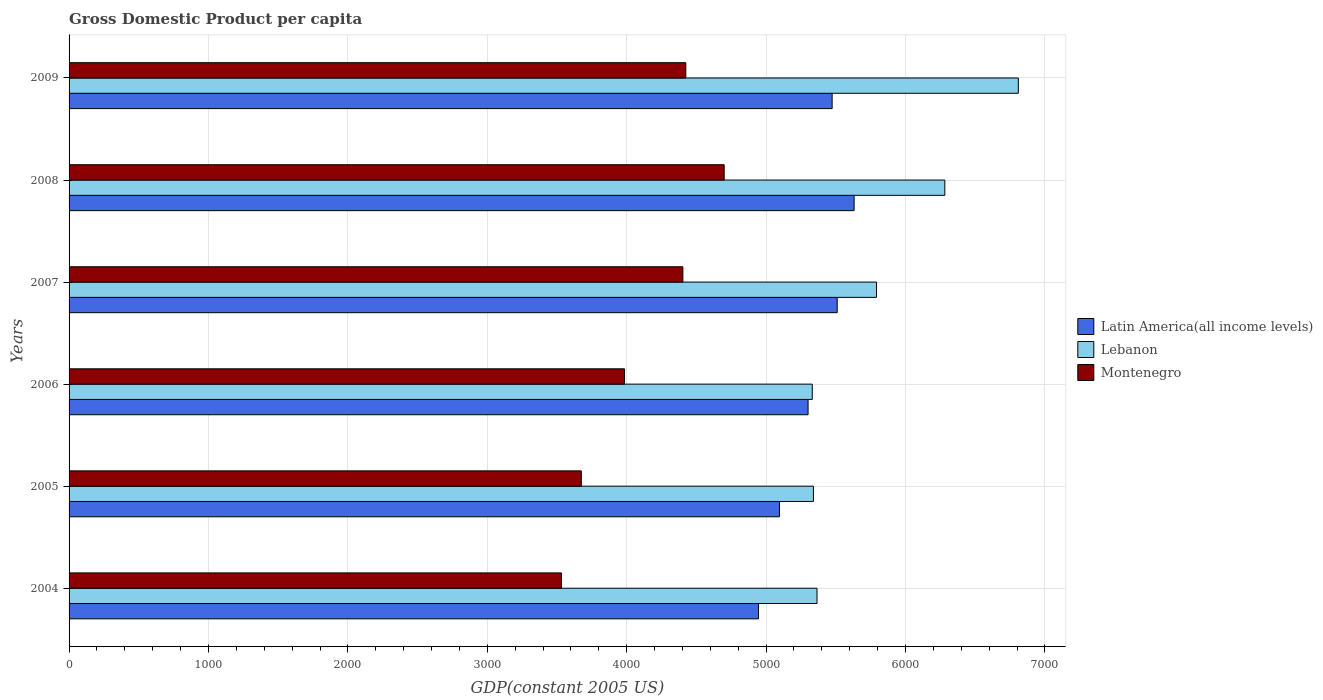How many different coloured bars are there?
Give a very brief answer. 3. Are the number of bars on each tick of the Y-axis equal?
Give a very brief answer. Yes. How many bars are there on the 5th tick from the bottom?
Make the answer very short. 3. What is the label of the 1st group of bars from the top?
Keep it short and to the point. 2009. What is the GDP per capita in Montenegro in 2009?
Provide a succinct answer. 4424.01. Across all years, what is the maximum GDP per capita in Montenegro?
Keep it short and to the point. 4699.35. Across all years, what is the minimum GDP per capita in Latin America(all income levels)?
Your answer should be very brief. 4945.3. What is the total GDP per capita in Montenegro in the graph?
Ensure brevity in your answer.  2.47e+04. What is the difference between the GDP per capita in Lebanon in 2004 and that in 2009?
Provide a succinct answer. -1444.07. What is the difference between the GDP per capita in Lebanon in 2006 and the GDP per capita in Latin America(all income levels) in 2009?
Give a very brief answer. -142.56. What is the average GDP per capita in Latin America(all income levels) per year?
Offer a very short reply. 5326.24. In the year 2004, what is the difference between the GDP per capita in Montenegro and GDP per capita in Lebanon?
Your response must be concise. -1833.38. In how many years, is the GDP per capita in Montenegro greater than 4000 US$?
Provide a succinct answer. 3. What is the ratio of the GDP per capita in Latin America(all income levels) in 2005 to that in 2008?
Provide a short and direct response. 0.9. Is the GDP per capita in Latin America(all income levels) in 2005 less than that in 2008?
Your answer should be very brief. Yes. What is the difference between the highest and the second highest GDP per capita in Latin America(all income levels)?
Offer a terse response. 121.24. What is the difference between the highest and the lowest GDP per capita in Lebanon?
Provide a succinct answer. 1478.16. In how many years, is the GDP per capita in Latin America(all income levels) greater than the average GDP per capita in Latin America(all income levels) taken over all years?
Give a very brief answer. 3. Is the sum of the GDP per capita in Montenegro in 2006 and 2009 greater than the maximum GDP per capita in Latin America(all income levels) across all years?
Your answer should be compact. Yes. What does the 2nd bar from the top in 2006 represents?
Your answer should be very brief. Lebanon. What does the 1st bar from the bottom in 2004 represents?
Make the answer very short. Latin America(all income levels). Is it the case that in every year, the sum of the GDP per capita in Lebanon and GDP per capita in Montenegro is greater than the GDP per capita in Latin America(all income levels)?
Ensure brevity in your answer.  Yes. Are all the bars in the graph horizontal?
Make the answer very short. Yes. What is the difference between two consecutive major ticks on the X-axis?
Your response must be concise. 1000. Where does the legend appear in the graph?
Keep it short and to the point. Center right. How many legend labels are there?
Provide a succinct answer. 3. What is the title of the graph?
Offer a terse response. Gross Domestic Product per capita. Does "Venezuela" appear as one of the legend labels in the graph?
Your answer should be compact. No. What is the label or title of the X-axis?
Offer a terse response. GDP(constant 2005 US). What is the GDP(constant 2005 US) of Latin America(all income levels) in 2004?
Your answer should be very brief. 4945.3. What is the GDP(constant 2005 US) of Lebanon in 2004?
Provide a succinct answer. 5365.26. What is the GDP(constant 2005 US) in Montenegro in 2004?
Make the answer very short. 3531.87. What is the GDP(constant 2005 US) in Latin America(all income levels) in 2005?
Keep it short and to the point. 5095.9. What is the GDP(constant 2005 US) of Lebanon in 2005?
Ensure brevity in your answer.  5339.42. What is the GDP(constant 2005 US) in Montenegro in 2005?
Ensure brevity in your answer.  3674.53. What is the GDP(constant 2005 US) in Latin America(all income levels) in 2006?
Provide a succinct answer. 5301.13. What is the GDP(constant 2005 US) of Lebanon in 2006?
Provide a succinct answer. 5331.16. What is the GDP(constant 2005 US) in Montenegro in 2006?
Ensure brevity in your answer.  3984.34. What is the GDP(constant 2005 US) in Latin America(all income levels) in 2007?
Offer a terse response. 5510.07. What is the GDP(constant 2005 US) of Lebanon in 2007?
Keep it short and to the point. 5791.99. What is the GDP(constant 2005 US) in Montenegro in 2007?
Your answer should be compact. 4402.9. What is the GDP(constant 2005 US) of Latin America(all income levels) in 2008?
Provide a short and direct response. 5631.31. What is the GDP(constant 2005 US) in Lebanon in 2008?
Make the answer very short. 6282.1. What is the GDP(constant 2005 US) in Montenegro in 2008?
Ensure brevity in your answer.  4699.35. What is the GDP(constant 2005 US) of Latin America(all income levels) in 2009?
Your answer should be compact. 5473.72. What is the GDP(constant 2005 US) of Lebanon in 2009?
Provide a succinct answer. 6809.32. What is the GDP(constant 2005 US) in Montenegro in 2009?
Your answer should be very brief. 4424.01. Across all years, what is the maximum GDP(constant 2005 US) in Latin America(all income levels)?
Provide a short and direct response. 5631.31. Across all years, what is the maximum GDP(constant 2005 US) in Lebanon?
Make the answer very short. 6809.32. Across all years, what is the maximum GDP(constant 2005 US) in Montenegro?
Offer a terse response. 4699.35. Across all years, what is the minimum GDP(constant 2005 US) in Latin America(all income levels)?
Make the answer very short. 4945.3. Across all years, what is the minimum GDP(constant 2005 US) in Lebanon?
Your answer should be very brief. 5331.16. Across all years, what is the minimum GDP(constant 2005 US) in Montenegro?
Make the answer very short. 3531.87. What is the total GDP(constant 2005 US) of Latin America(all income levels) in the graph?
Your answer should be very brief. 3.20e+04. What is the total GDP(constant 2005 US) of Lebanon in the graph?
Keep it short and to the point. 3.49e+04. What is the total GDP(constant 2005 US) of Montenegro in the graph?
Make the answer very short. 2.47e+04. What is the difference between the GDP(constant 2005 US) in Latin America(all income levels) in 2004 and that in 2005?
Give a very brief answer. -150.6. What is the difference between the GDP(constant 2005 US) in Lebanon in 2004 and that in 2005?
Provide a succinct answer. 25.83. What is the difference between the GDP(constant 2005 US) in Montenegro in 2004 and that in 2005?
Provide a succinct answer. -142.65. What is the difference between the GDP(constant 2005 US) in Latin America(all income levels) in 2004 and that in 2006?
Your answer should be very brief. -355.83. What is the difference between the GDP(constant 2005 US) in Lebanon in 2004 and that in 2006?
Offer a terse response. 34.09. What is the difference between the GDP(constant 2005 US) in Montenegro in 2004 and that in 2006?
Offer a terse response. -452.46. What is the difference between the GDP(constant 2005 US) in Latin America(all income levels) in 2004 and that in 2007?
Your answer should be very brief. -564.77. What is the difference between the GDP(constant 2005 US) in Lebanon in 2004 and that in 2007?
Ensure brevity in your answer.  -426.73. What is the difference between the GDP(constant 2005 US) in Montenegro in 2004 and that in 2007?
Your answer should be very brief. -871.03. What is the difference between the GDP(constant 2005 US) in Latin America(all income levels) in 2004 and that in 2008?
Offer a very short reply. -686.01. What is the difference between the GDP(constant 2005 US) in Lebanon in 2004 and that in 2008?
Ensure brevity in your answer.  -916.84. What is the difference between the GDP(constant 2005 US) of Montenegro in 2004 and that in 2008?
Ensure brevity in your answer.  -1167.47. What is the difference between the GDP(constant 2005 US) in Latin America(all income levels) in 2004 and that in 2009?
Provide a succinct answer. -528.43. What is the difference between the GDP(constant 2005 US) of Lebanon in 2004 and that in 2009?
Provide a short and direct response. -1444.07. What is the difference between the GDP(constant 2005 US) in Montenegro in 2004 and that in 2009?
Provide a succinct answer. -892.13. What is the difference between the GDP(constant 2005 US) in Latin America(all income levels) in 2005 and that in 2006?
Offer a terse response. -205.23. What is the difference between the GDP(constant 2005 US) of Lebanon in 2005 and that in 2006?
Offer a terse response. 8.26. What is the difference between the GDP(constant 2005 US) in Montenegro in 2005 and that in 2006?
Your answer should be very brief. -309.81. What is the difference between the GDP(constant 2005 US) in Latin America(all income levels) in 2005 and that in 2007?
Give a very brief answer. -414.17. What is the difference between the GDP(constant 2005 US) of Lebanon in 2005 and that in 2007?
Make the answer very short. -452.56. What is the difference between the GDP(constant 2005 US) of Montenegro in 2005 and that in 2007?
Offer a very short reply. -728.38. What is the difference between the GDP(constant 2005 US) of Latin America(all income levels) in 2005 and that in 2008?
Provide a short and direct response. -535.41. What is the difference between the GDP(constant 2005 US) of Lebanon in 2005 and that in 2008?
Offer a terse response. -942.68. What is the difference between the GDP(constant 2005 US) in Montenegro in 2005 and that in 2008?
Offer a very short reply. -1024.82. What is the difference between the GDP(constant 2005 US) in Latin America(all income levels) in 2005 and that in 2009?
Your answer should be very brief. -377.83. What is the difference between the GDP(constant 2005 US) of Lebanon in 2005 and that in 2009?
Your answer should be compact. -1469.9. What is the difference between the GDP(constant 2005 US) in Montenegro in 2005 and that in 2009?
Make the answer very short. -749.48. What is the difference between the GDP(constant 2005 US) in Latin America(all income levels) in 2006 and that in 2007?
Give a very brief answer. -208.94. What is the difference between the GDP(constant 2005 US) in Lebanon in 2006 and that in 2007?
Your response must be concise. -460.82. What is the difference between the GDP(constant 2005 US) in Montenegro in 2006 and that in 2007?
Make the answer very short. -418.56. What is the difference between the GDP(constant 2005 US) of Latin America(all income levels) in 2006 and that in 2008?
Your answer should be compact. -330.18. What is the difference between the GDP(constant 2005 US) of Lebanon in 2006 and that in 2008?
Your response must be concise. -950.94. What is the difference between the GDP(constant 2005 US) of Montenegro in 2006 and that in 2008?
Provide a succinct answer. -715.01. What is the difference between the GDP(constant 2005 US) of Latin America(all income levels) in 2006 and that in 2009?
Provide a succinct answer. -172.6. What is the difference between the GDP(constant 2005 US) in Lebanon in 2006 and that in 2009?
Your answer should be very brief. -1478.16. What is the difference between the GDP(constant 2005 US) of Montenegro in 2006 and that in 2009?
Your answer should be very brief. -439.67. What is the difference between the GDP(constant 2005 US) in Latin America(all income levels) in 2007 and that in 2008?
Keep it short and to the point. -121.24. What is the difference between the GDP(constant 2005 US) in Lebanon in 2007 and that in 2008?
Your response must be concise. -490.11. What is the difference between the GDP(constant 2005 US) of Montenegro in 2007 and that in 2008?
Ensure brevity in your answer.  -296.45. What is the difference between the GDP(constant 2005 US) in Latin America(all income levels) in 2007 and that in 2009?
Offer a terse response. 36.35. What is the difference between the GDP(constant 2005 US) in Lebanon in 2007 and that in 2009?
Provide a short and direct response. -1017.34. What is the difference between the GDP(constant 2005 US) of Montenegro in 2007 and that in 2009?
Offer a terse response. -21.11. What is the difference between the GDP(constant 2005 US) of Latin America(all income levels) in 2008 and that in 2009?
Provide a short and direct response. 157.59. What is the difference between the GDP(constant 2005 US) in Lebanon in 2008 and that in 2009?
Offer a very short reply. -527.22. What is the difference between the GDP(constant 2005 US) in Montenegro in 2008 and that in 2009?
Keep it short and to the point. 275.34. What is the difference between the GDP(constant 2005 US) of Latin America(all income levels) in 2004 and the GDP(constant 2005 US) of Lebanon in 2005?
Keep it short and to the point. -394.13. What is the difference between the GDP(constant 2005 US) in Latin America(all income levels) in 2004 and the GDP(constant 2005 US) in Montenegro in 2005?
Keep it short and to the point. 1270.77. What is the difference between the GDP(constant 2005 US) of Lebanon in 2004 and the GDP(constant 2005 US) of Montenegro in 2005?
Ensure brevity in your answer.  1690.73. What is the difference between the GDP(constant 2005 US) of Latin America(all income levels) in 2004 and the GDP(constant 2005 US) of Lebanon in 2006?
Give a very brief answer. -385.87. What is the difference between the GDP(constant 2005 US) in Latin America(all income levels) in 2004 and the GDP(constant 2005 US) in Montenegro in 2006?
Ensure brevity in your answer.  960.96. What is the difference between the GDP(constant 2005 US) of Lebanon in 2004 and the GDP(constant 2005 US) of Montenegro in 2006?
Your answer should be compact. 1380.92. What is the difference between the GDP(constant 2005 US) in Latin America(all income levels) in 2004 and the GDP(constant 2005 US) in Lebanon in 2007?
Ensure brevity in your answer.  -846.69. What is the difference between the GDP(constant 2005 US) of Latin America(all income levels) in 2004 and the GDP(constant 2005 US) of Montenegro in 2007?
Offer a very short reply. 542.39. What is the difference between the GDP(constant 2005 US) in Lebanon in 2004 and the GDP(constant 2005 US) in Montenegro in 2007?
Ensure brevity in your answer.  962.35. What is the difference between the GDP(constant 2005 US) in Latin America(all income levels) in 2004 and the GDP(constant 2005 US) in Lebanon in 2008?
Your answer should be compact. -1336.8. What is the difference between the GDP(constant 2005 US) in Latin America(all income levels) in 2004 and the GDP(constant 2005 US) in Montenegro in 2008?
Give a very brief answer. 245.95. What is the difference between the GDP(constant 2005 US) of Lebanon in 2004 and the GDP(constant 2005 US) of Montenegro in 2008?
Keep it short and to the point. 665.91. What is the difference between the GDP(constant 2005 US) in Latin America(all income levels) in 2004 and the GDP(constant 2005 US) in Lebanon in 2009?
Give a very brief answer. -1864.03. What is the difference between the GDP(constant 2005 US) of Latin America(all income levels) in 2004 and the GDP(constant 2005 US) of Montenegro in 2009?
Give a very brief answer. 521.29. What is the difference between the GDP(constant 2005 US) in Lebanon in 2004 and the GDP(constant 2005 US) in Montenegro in 2009?
Offer a very short reply. 941.25. What is the difference between the GDP(constant 2005 US) of Latin America(all income levels) in 2005 and the GDP(constant 2005 US) of Lebanon in 2006?
Provide a short and direct response. -235.27. What is the difference between the GDP(constant 2005 US) of Latin America(all income levels) in 2005 and the GDP(constant 2005 US) of Montenegro in 2006?
Ensure brevity in your answer.  1111.56. What is the difference between the GDP(constant 2005 US) of Lebanon in 2005 and the GDP(constant 2005 US) of Montenegro in 2006?
Offer a terse response. 1355.08. What is the difference between the GDP(constant 2005 US) of Latin America(all income levels) in 2005 and the GDP(constant 2005 US) of Lebanon in 2007?
Your answer should be compact. -696.09. What is the difference between the GDP(constant 2005 US) of Latin America(all income levels) in 2005 and the GDP(constant 2005 US) of Montenegro in 2007?
Offer a very short reply. 692.99. What is the difference between the GDP(constant 2005 US) in Lebanon in 2005 and the GDP(constant 2005 US) in Montenegro in 2007?
Your response must be concise. 936.52. What is the difference between the GDP(constant 2005 US) in Latin America(all income levels) in 2005 and the GDP(constant 2005 US) in Lebanon in 2008?
Your answer should be compact. -1186.2. What is the difference between the GDP(constant 2005 US) of Latin America(all income levels) in 2005 and the GDP(constant 2005 US) of Montenegro in 2008?
Your response must be concise. 396.55. What is the difference between the GDP(constant 2005 US) of Lebanon in 2005 and the GDP(constant 2005 US) of Montenegro in 2008?
Make the answer very short. 640.07. What is the difference between the GDP(constant 2005 US) of Latin America(all income levels) in 2005 and the GDP(constant 2005 US) of Lebanon in 2009?
Your answer should be compact. -1713.43. What is the difference between the GDP(constant 2005 US) in Latin America(all income levels) in 2005 and the GDP(constant 2005 US) in Montenegro in 2009?
Provide a short and direct response. 671.89. What is the difference between the GDP(constant 2005 US) in Lebanon in 2005 and the GDP(constant 2005 US) in Montenegro in 2009?
Provide a succinct answer. 915.41. What is the difference between the GDP(constant 2005 US) in Latin America(all income levels) in 2006 and the GDP(constant 2005 US) in Lebanon in 2007?
Provide a succinct answer. -490.86. What is the difference between the GDP(constant 2005 US) in Latin America(all income levels) in 2006 and the GDP(constant 2005 US) in Montenegro in 2007?
Provide a short and direct response. 898.22. What is the difference between the GDP(constant 2005 US) in Lebanon in 2006 and the GDP(constant 2005 US) in Montenegro in 2007?
Your response must be concise. 928.26. What is the difference between the GDP(constant 2005 US) in Latin America(all income levels) in 2006 and the GDP(constant 2005 US) in Lebanon in 2008?
Provide a succinct answer. -980.97. What is the difference between the GDP(constant 2005 US) of Latin America(all income levels) in 2006 and the GDP(constant 2005 US) of Montenegro in 2008?
Ensure brevity in your answer.  601.78. What is the difference between the GDP(constant 2005 US) in Lebanon in 2006 and the GDP(constant 2005 US) in Montenegro in 2008?
Provide a succinct answer. 631.82. What is the difference between the GDP(constant 2005 US) in Latin America(all income levels) in 2006 and the GDP(constant 2005 US) in Lebanon in 2009?
Ensure brevity in your answer.  -1508.2. What is the difference between the GDP(constant 2005 US) in Latin America(all income levels) in 2006 and the GDP(constant 2005 US) in Montenegro in 2009?
Your answer should be compact. 877.12. What is the difference between the GDP(constant 2005 US) in Lebanon in 2006 and the GDP(constant 2005 US) in Montenegro in 2009?
Keep it short and to the point. 907.15. What is the difference between the GDP(constant 2005 US) of Latin America(all income levels) in 2007 and the GDP(constant 2005 US) of Lebanon in 2008?
Offer a very short reply. -772.03. What is the difference between the GDP(constant 2005 US) in Latin America(all income levels) in 2007 and the GDP(constant 2005 US) in Montenegro in 2008?
Give a very brief answer. 810.72. What is the difference between the GDP(constant 2005 US) in Lebanon in 2007 and the GDP(constant 2005 US) in Montenegro in 2008?
Keep it short and to the point. 1092.64. What is the difference between the GDP(constant 2005 US) in Latin America(all income levels) in 2007 and the GDP(constant 2005 US) in Lebanon in 2009?
Keep it short and to the point. -1299.26. What is the difference between the GDP(constant 2005 US) in Latin America(all income levels) in 2007 and the GDP(constant 2005 US) in Montenegro in 2009?
Provide a succinct answer. 1086.06. What is the difference between the GDP(constant 2005 US) in Lebanon in 2007 and the GDP(constant 2005 US) in Montenegro in 2009?
Give a very brief answer. 1367.98. What is the difference between the GDP(constant 2005 US) of Latin America(all income levels) in 2008 and the GDP(constant 2005 US) of Lebanon in 2009?
Keep it short and to the point. -1178.01. What is the difference between the GDP(constant 2005 US) in Latin America(all income levels) in 2008 and the GDP(constant 2005 US) in Montenegro in 2009?
Keep it short and to the point. 1207.3. What is the difference between the GDP(constant 2005 US) of Lebanon in 2008 and the GDP(constant 2005 US) of Montenegro in 2009?
Your answer should be very brief. 1858.09. What is the average GDP(constant 2005 US) of Latin America(all income levels) per year?
Your response must be concise. 5326.24. What is the average GDP(constant 2005 US) in Lebanon per year?
Keep it short and to the point. 5819.88. What is the average GDP(constant 2005 US) in Montenegro per year?
Make the answer very short. 4119.5. In the year 2004, what is the difference between the GDP(constant 2005 US) in Latin America(all income levels) and GDP(constant 2005 US) in Lebanon?
Ensure brevity in your answer.  -419.96. In the year 2004, what is the difference between the GDP(constant 2005 US) in Latin America(all income levels) and GDP(constant 2005 US) in Montenegro?
Your answer should be compact. 1413.42. In the year 2004, what is the difference between the GDP(constant 2005 US) in Lebanon and GDP(constant 2005 US) in Montenegro?
Make the answer very short. 1833.38. In the year 2005, what is the difference between the GDP(constant 2005 US) of Latin America(all income levels) and GDP(constant 2005 US) of Lebanon?
Provide a succinct answer. -243.53. In the year 2005, what is the difference between the GDP(constant 2005 US) in Latin America(all income levels) and GDP(constant 2005 US) in Montenegro?
Ensure brevity in your answer.  1421.37. In the year 2005, what is the difference between the GDP(constant 2005 US) in Lebanon and GDP(constant 2005 US) in Montenegro?
Provide a short and direct response. 1664.9. In the year 2006, what is the difference between the GDP(constant 2005 US) in Latin America(all income levels) and GDP(constant 2005 US) in Lebanon?
Give a very brief answer. -30.04. In the year 2006, what is the difference between the GDP(constant 2005 US) in Latin America(all income levels) and GDP(constant 2005 US) in Montenegro?
Your response must be concise. 1316.79. In the year 2006, what is the difference between the GDP(constant 2005 US) of Lebanon and GDP(constant 2005 US) of Montenegro?
Make the answer very short. 1346.82. In the year 2007, what is the difference between the GDP(constant 2005 US) in Latin America(all income levels) and GDP(constant 2005 US) in Lebanon?
Make the answer very short. -281.92. In the year 2007, what is the difference between the GDP(constant 2005 US) of Latin America(all income levels) and GDP(constant 2005 US) of Montenegro?
Your answer should be very brief. 1107.17. In the year 2007, what is the difference between the GDP(constant 2005 US) in Lebanon and GDP(constant 2005 US) in Montenegro?
Keep it short and to the point. 1389.09. In the year 2008, what is the difference between the GDP(constant 2005 US) of Latin America(all income levels) and GDP(constant 2005 US) of Lebanon?
Ensure brevity in your answer.  -650.79. In the year 2008, what is the difference between the GDP(constant 2005 US) of Latin America(all income levels) and GDP(constant 2005 US) of Montenegro?
Your answer should be compact. 931.96. In the year 2008, what is the difference between the GDP(constant 2005 US) in Lebanon and GDP(constant 2005 US) in Montenegro?
Your answer should be compact. 1582.75. In the year 2009, what is the difference between the GDP(constant 2005 US) of Latin America(all income levels) and GDP(constant 2005 US) of Lebanon?
Provide a succinct answer. -1335.6. In the year 2009, what is the difference between the GDP(constant 2005 US) of Latin America(all income levels) and GDP(constant 2005 US) of Montenegro?
Ensure brevity in your answer.  1049.71. In the year 2009, what is the difference between the GDP(constant 2005 US) of Lebanon and GDP(constant 2005 US) of Montenegro?
Make the answer very short. 2385.31. What is the ratio of the GDP(constant 2005 US) in Latin America(all income levels) in 2004 to that in 2005?
Keep it short and to the point. 0.97. What is the ratio of the GDP(constant 2005 US) of Montenegro in 2004 to that in 2005?
Your answer should be compact. 0.96. What is the ratio of the GDP(constant 2005 US) in Latin America(all income levels) in 2004 to that in 2006?
Ensure brevity in your answer.  0.93. What is the ratio of the GDP(constant 2005 US) of Lebanon in 2004 to that in 2006?
Your answer should be very brief. 1.01. What is the ratio of the GDP(constant 2005 US) in Montenegro in 2004 to that in 2006?
Offer a terse response. 0.89. What is the ratio of the GDP(constant 2005 US) of Latin America(all income levels) in 2004 to that in 2007?
Provide a succinct answer. 0.9. What is the ratio of the GDP(constant 2005 US) of Lebanon in 2004 to that in 2007?
Your answer should be compact. 0.93. What is the ratio of the GDP(constant 2005 US) in Montenegro in 2004 to that in 2007?
Ensure brevity in your answer.  0.8. What is the ratio of the GDP(constant 2005 US) of Latin America(all income levels) in 2004 to that in 2008?
Make the answer very short. 0.88. What is the ratio of the GDP(constant 2005 US) of Lebanon in 2004 to that in 2008?
Offer a very short reply. 0.85. What is the ratio of the GDP(constant 2005 US) in Montenegro in 2004 to that in 2008?
Your answer should be compact. 0.75. What is the ratio of the GDP(constant 2005 US) in Latin America(all income levels) in 2004 to that in 2009?
Ensure brevity in your answer.  0.9. What is the ratio of the GDP(constant 2005 US) of Lebanon in 2004 to that in 2009?
Provide a short and direct response. 0.79. What is the ratio of the GDP(constant 2005 US) in Montenegro in 2004 to that in 2009?
Ensure brevity in your answer.  0.8. What is the ratio of the GDP(constant 2005 US) of Latin America(all income levels) in 2005 to that in 2006?
Ensure brevity in your answer.  0.96. What is the ratio of the GDP(constant 2005 US) in Montenegro in 2005 to that in 2006?
Your answer should be compact. 0.92. What is the ratio of the GDP(constant 2005 US) in Latin America(all income levels) in 2005 to that in 2007?
Give a very brief answer. 0.92. What is the ratio of the GDP(constant 2005 US) of Lebanon in 2005 to that in 2007?
Make the answer very short. 0.92. What is the ratio of the GDP(constant 2005 US) of Montenegro in 2005 to that in 2007?
Your response must be concise. 0.83. What is the ratio of the GDP(constant 2005 US) of Latin America(all income levels) in 2005 to that in 2008?
Your response must be concise. 0.9. What is the ratio of the GDP(constant 2005 US) in Lebanon in 2005 to that in 2008?
Your answer should be very brief. 0.85. What is the ratio of the GDP(constant 2005 US) of Montenegro in 2005 to that in 2008?
Keep it short and to the point. 0.78. What is the ratio of the GDP(constant 2005 US) of Latin America(all income levels) in 2005 to that in 2009?
Your response must be concise. 0.93. What is the ratio of the GDP(constant 2005 US) in Lebanon in 2005 to that in 2009?
Your answer should be very brief. 0.78. What is the ratio of the GDP(constant 2005 US) in Montenegro in 2005 to that in 2009?
Keep it short and to the point. 0.83. What is the ratio of the GDP(constant 2005 US) in Latin America(all income levels) in 2006 to that in 2007?
Keep it short and to the point. 0.96. What is the ratio of the GDP(constant 2005 US) in Lebanon in 2006 to that in 2007?
Your answer should be very brief. 0.92. What is the ratio of the GDP(constant 2005 US) in Montenegro in 2006 to that in 2007?
Give a very brief answer. 0.9. What is the ratio of the GDP(constant 2005 US) of Latin America(all income levels) in 2006 to that in 2008?
Provide a short and direct response. 0.94. What is the ratio of the GDP(constant 2005 US) of Lebanon in 2006 to that in 2008?
Offer a very short reply. 0.85. What is the ratio of the GDP(constant 2005 US) of Montenegro in 2006 to that in 2008?
Give a very brief answer. 0.85. What is the ratio of the GDP(constant 2005 US) of Latin America(all income levels) in 2006 to that in 2009?
Offer a very short reply. 0.97. What is the ratio of the GDP(constant 2005 US) in Lebanon in 2006 to that in 2009?
Make the answer very short. 0.78. What is the ratio of the GDP(constant 2005 US) in Montenegro in 2006 to that in 2009?
Give a very brief answer. 0.9. What is the ratio of the GDP(constant 2005 US) of Latin America(all income levels) in 2007 to that in 2008?
Provide a succinct answer. 0.98. What is the ratio of the GDP(constant 2005 US) of Lebanon in 2007 to that in 2008?
Ensure brevity in your answer.  0.92. What is the ratio of the GDP(constant 2005 US) of Montenegro in 2007 to that in 2008?
Make the answer very short. 0.94. What is the ratio of the GDP(constant 2005 US) in Latin America(all income levels) in 2007 to that in 2009?
Ensure brevity in your answer.  1.01. What is the ratio of the GDP(constant 2005 US) in Lebanon in 2007 to that in 2009?
Your answer should be very brief. 0.85. What is the ratio of the GDP(constant 2005 US) in Latin America(all income levels) in 2008 to that in 2009?
Offer a very short reply. 1.03. What is the ratio of the GDP(constant 2005 US) of Lebanon in 2008 to that in 2009?
Give a very brief answer. 0.92. What is the ratio of the GDP(constant 2005 US) of Montenegro in 2008 to that in 2009?
Ensure brevity in your answer.  1.06. What is the difference between the highest and the second highest GDP(constant 2005 US) of Latin America(all income levels)?
Your response must be concise. 121.24. What is the difference between the highest and the second highest GDP(constant 2005 US) of Lebanon?
Your answer should be very brief. 527.22. What is the difference between the highest and the second highest GDP(constant 2005 US) of Montenegro?
Your response must be concise. 275.34. What is the difference between the highest and the lowest GDP(constant 2005 US) of Latin America(all income levels)?
Give a very brief answer. 686.01. What is the difference between the highest and the lowest GDP(constant 2005 US) of Lebanon?
Your answer should be very brief. 1478.16. What is the difference between the highest and the lowest GDP(constant 2005 US) of Montenegro?
Offer a very short reply. 1167.47. 